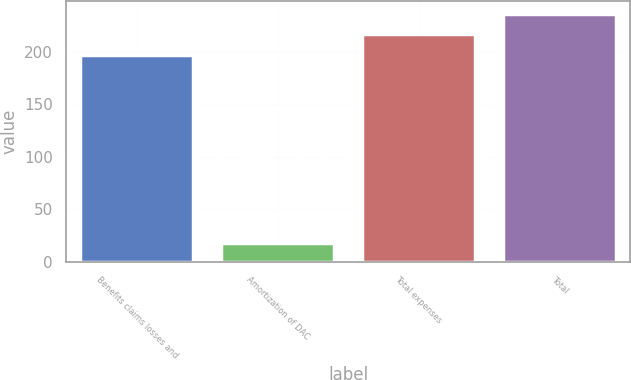Convert chart. <chart><loc_0><loc_0><loc_500><loc_500><bar_chart><fcel>Benefits claims losses and<fcel>Amortization of DAC<fcel>Total expenses<fcel>Total<nl><fcel>197<fcel>18<fcel>216.7<fcel>236.4<nl></chart> 